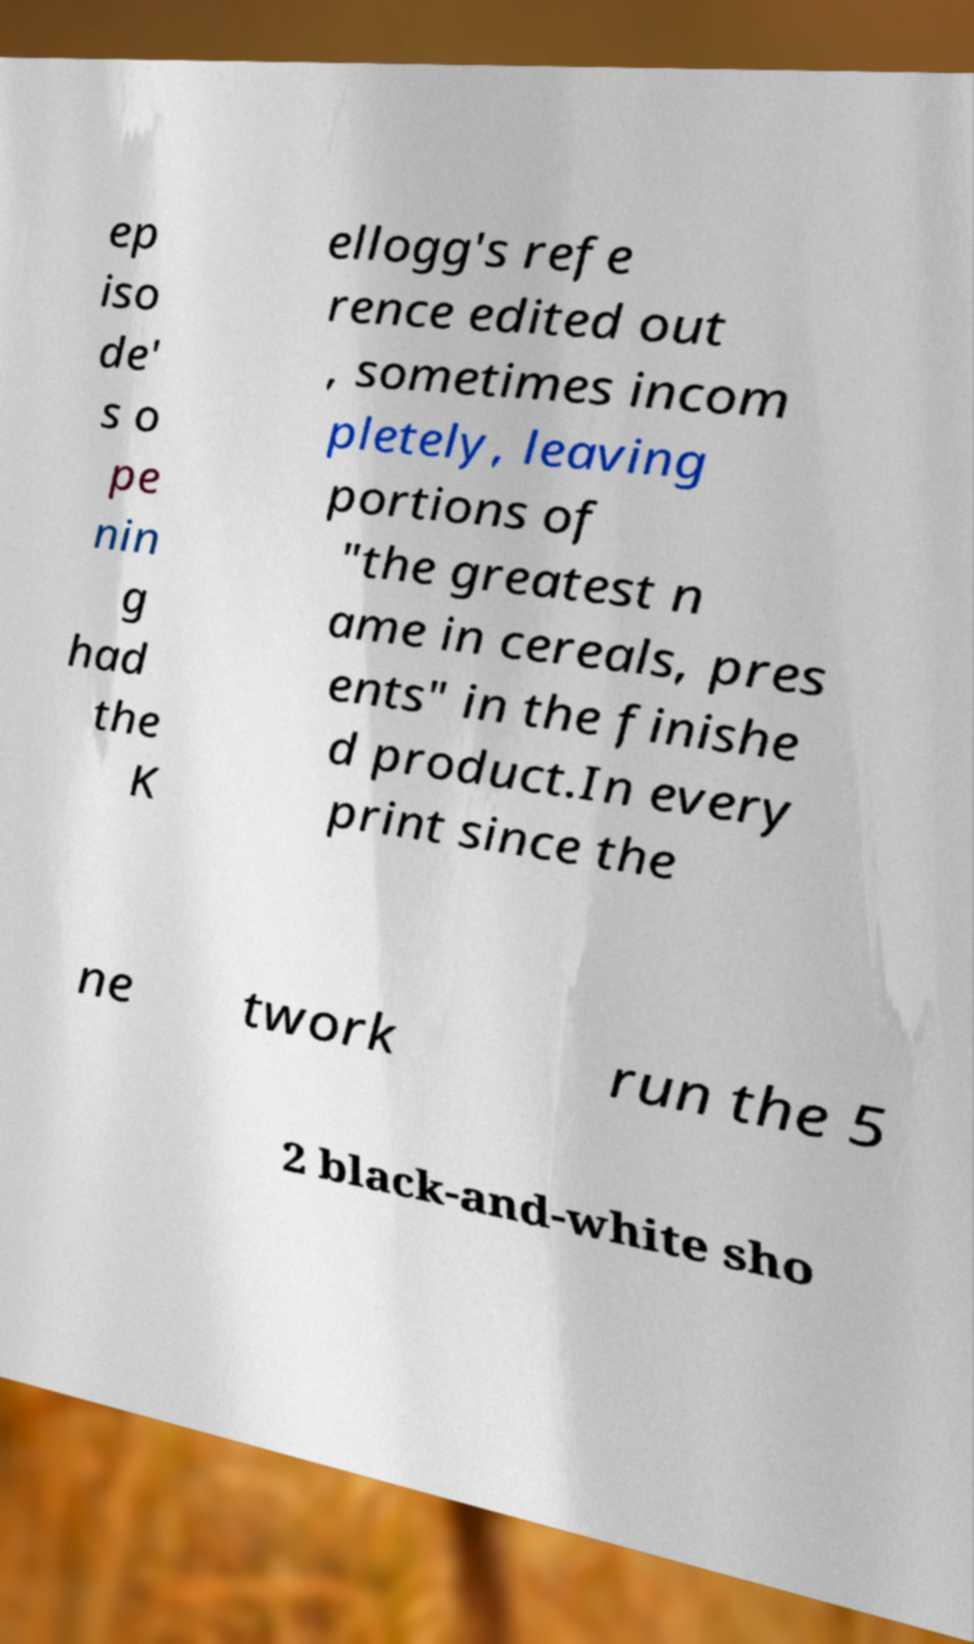I need the written content from this picture converted into text. Can you do that? ep iso de' s o pe nin g had the K ellogg's refe rence edited out , sometimes incom pletely, leaving portions of "the greatest n ame in cereals, pres ents" in the finishe d product.In every print since the ne twork run the 5 2 black-and-white sho 